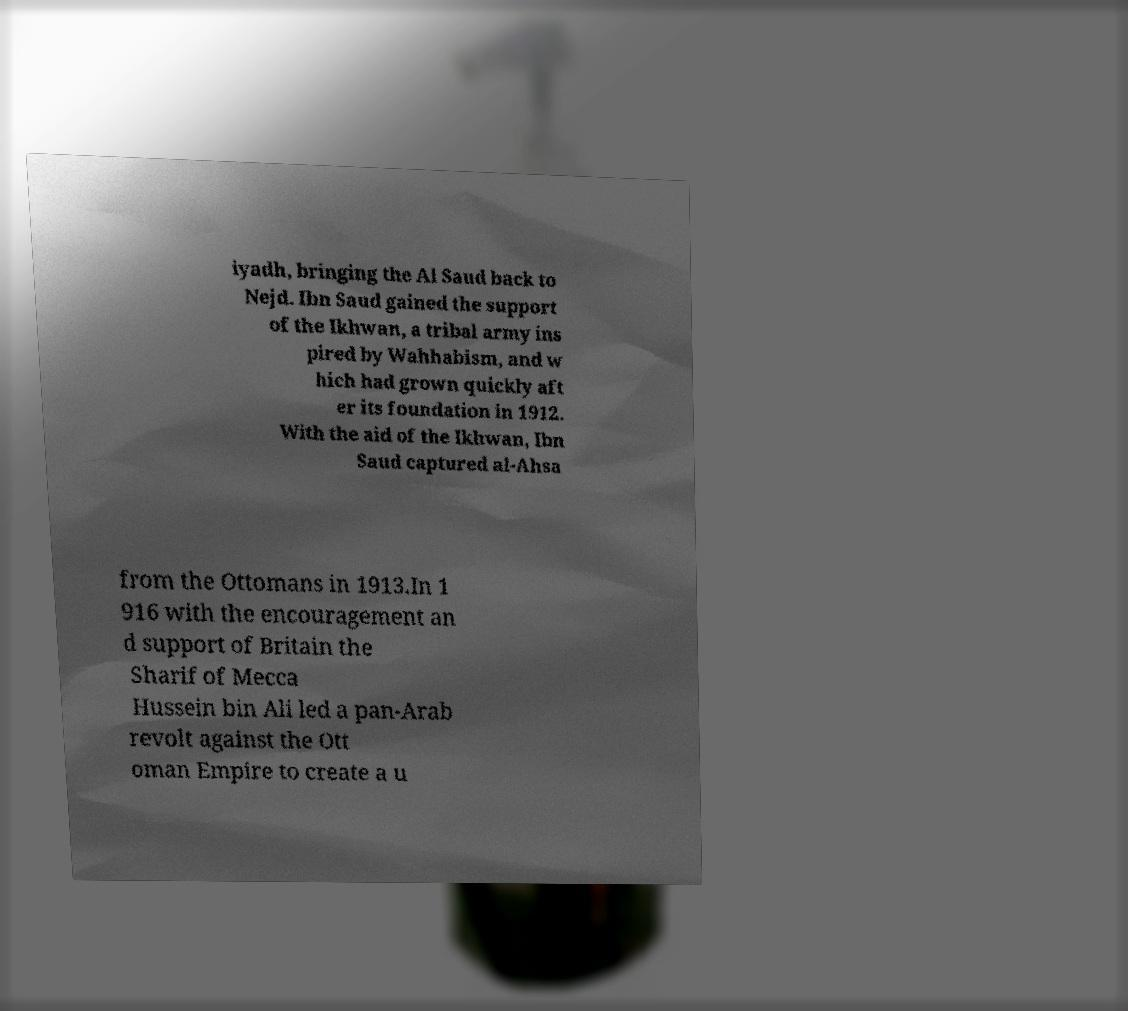Can you read and provide the text displayed in the image?This photo seems to have some interesting text. Can you extract and type it out for me? iyadh, bringing the Al Saud back to Nejd. Ibn Saud gained the support of the Ikhwan, a tribal army ins pired by Wahhabism, and w hich had grown quickly aft er its foundation in 1912. With the aid of the Ikhwan, Ibn Saud captured al-Ahsa from the Ottomans in 1913.In 1 916 with the encouragement an d support of Britain the Sharif of Mecca Hussein bin Ali led a pan-Arab revolt against the Ott oman Empire to create a u 